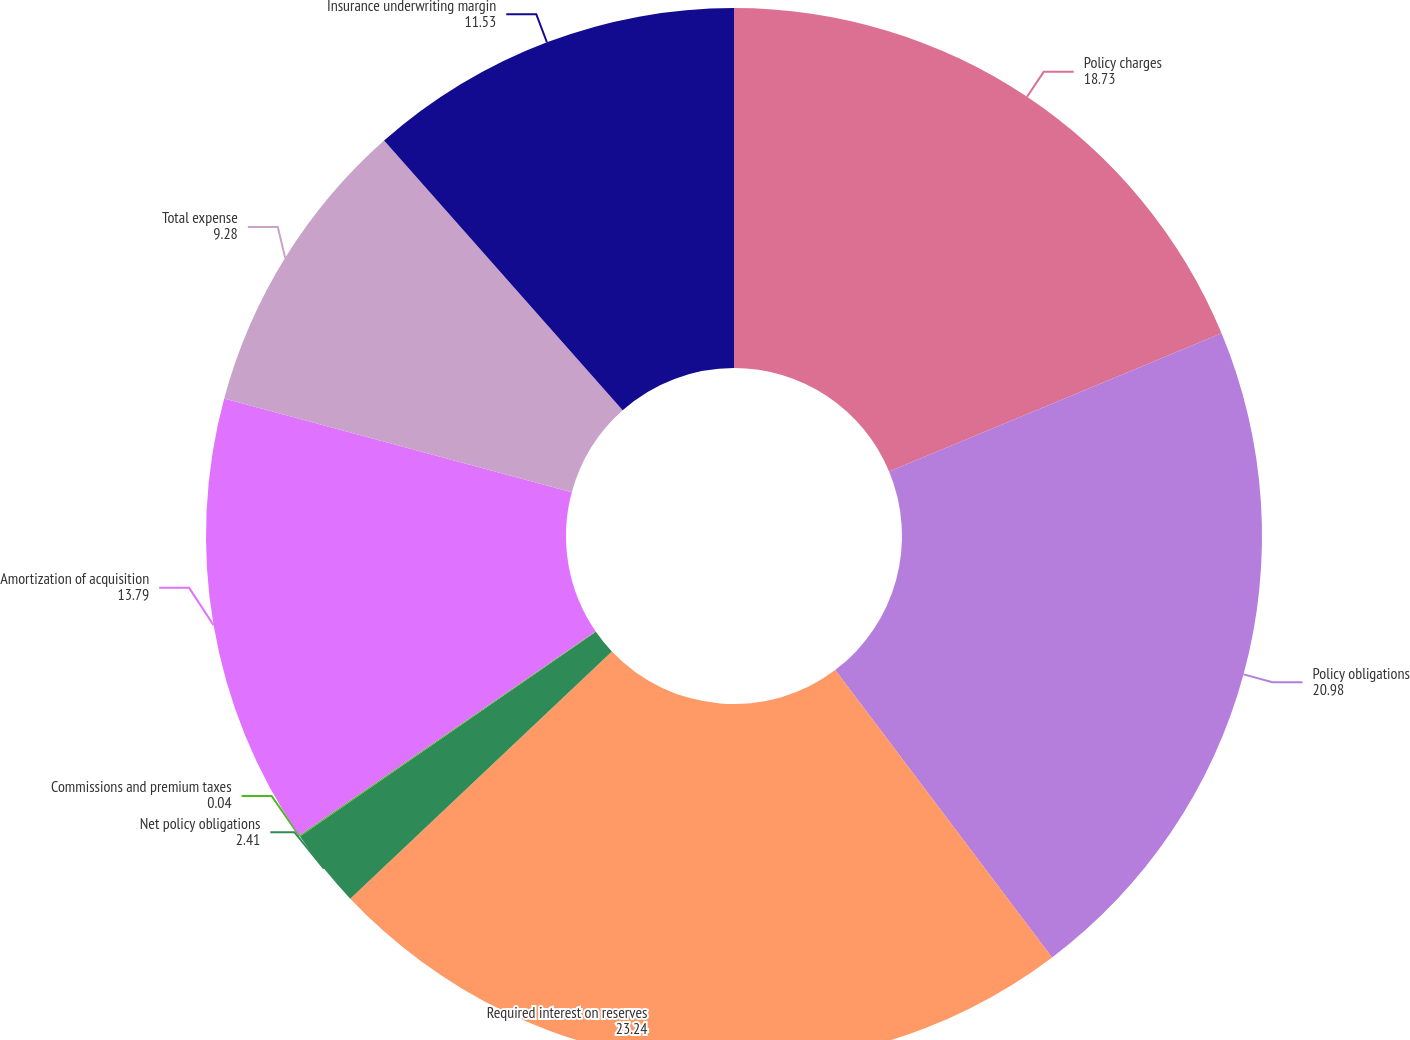Convert chart. <chart><loc_0><loc_0><loc_500><loc_500><pie_chart><fcel>Policy charges<fcel>Policy obligations<fcel>Required interest on reserves<fcel>Net policy obligations<fcel>Commissions and premium taxes<fcel>Amortization of acquisition<fcel>Total expense<fcel>Insurance underwriting margin<nl><fcel>18.73%<fcel>20.98%<fcel>23.24%<fcel>2.41%<fcel>0.04%<fcel>13.79%<fcel>9.28%<fcel>11.53%<nl></chart> 